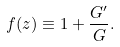<formula> <loc_0><loc_0><loc_500><loc_500>f ( z ) \equiv 1 + \frac { G ^ { \prime } } { G } .</formula> 